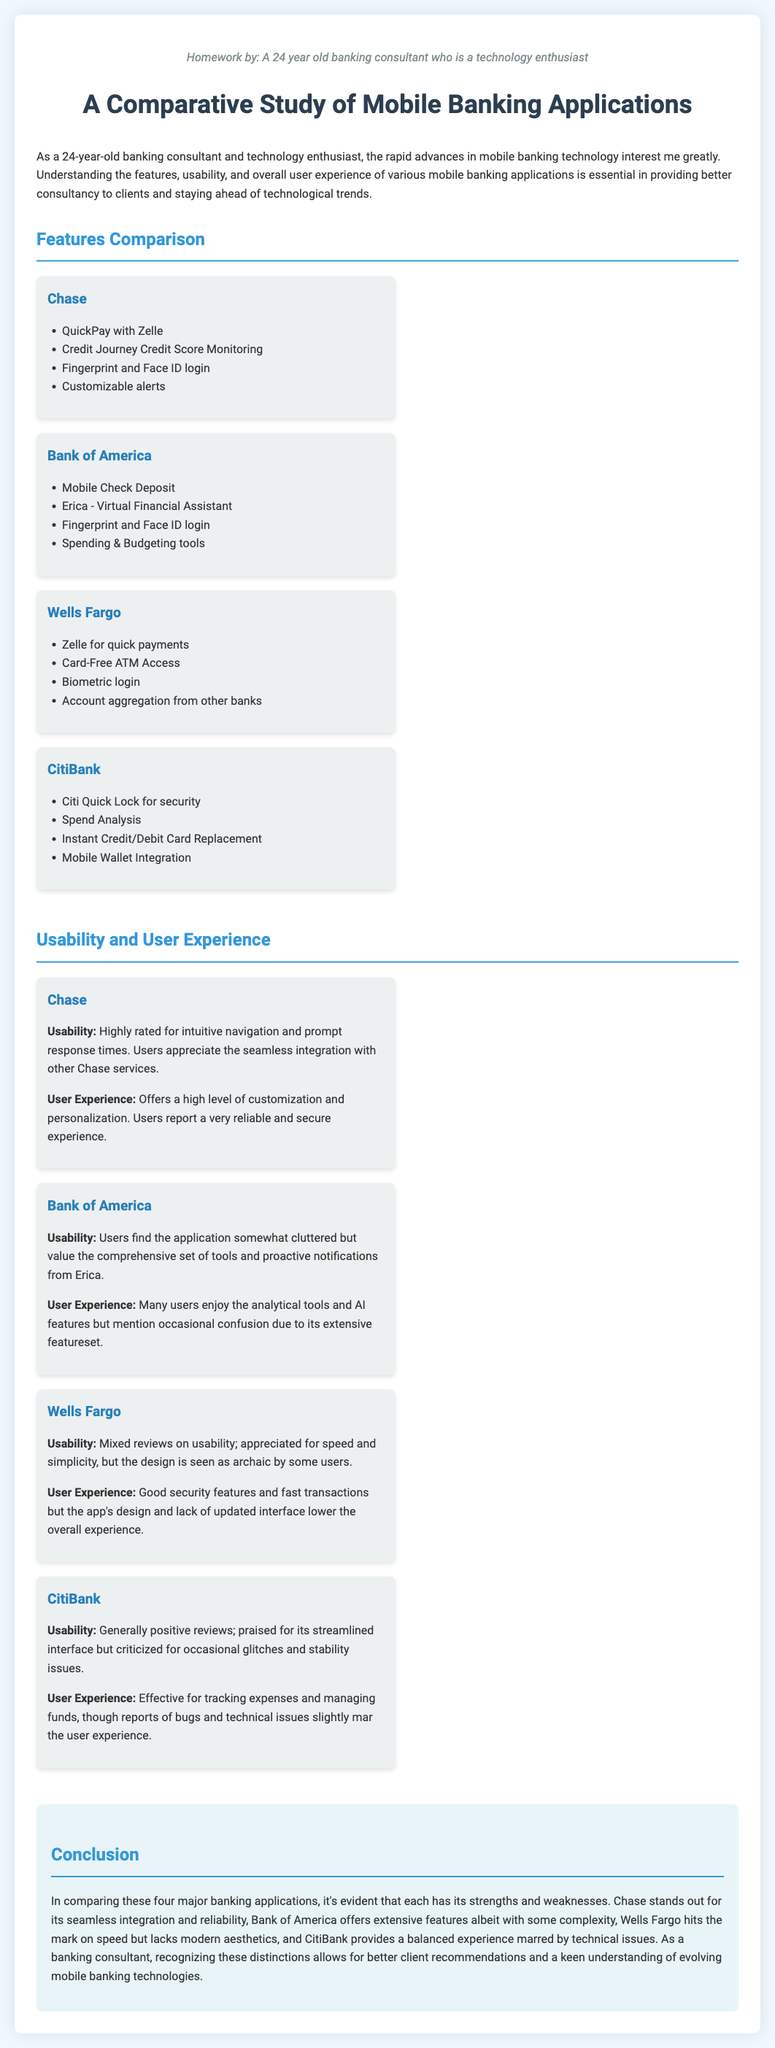What features does Chase offer? The features offered by Chase include QuickPay with Zelle, Credit Journey Credit Score Monitoring, Fingerprint and Face ID login, and Customizable alerts.
Answer: QuickPay with Zelle, Credit Journey Credit Score Monitoring, Fingerprint and Face ID login, Customizable alerts Which bank provides a Virtual Financial Assistant? The bank that offers a Virtual Financial Assistant is Bank of America.
Answer: Bank of America What is the user experience rating for Wells Fargo? Users report good security features and fast transactions but mention that the app's design and interface lower the overall experience.
Answer: Mixed Which bank has a feature called Citi Quick Lock? The bank with the feature Citi Quick Lock is CitiBank.
Answer: CitiBank How many banks are compared in this study? The total number of banks compared in this study is four.
Answer: Four What does CitiBank's user experience report mention about technical issues? The report states that CitiBank's user experience is marred by bugs and technical issues.
Answer: Bugs and technical issues What is a notable feature of Bank of America's app? A notable feature of Bank of America's app is Mobile Check Deposit.
Answer: Mobile Check Deposit Which bank is praised for seamless integration? Chase is praised for its seamless integration.
Answer: Chase What is the conclusion about Wells Fargo's design? The conclusion states that Wells Fargo's design is seen as archaic by some users.
Answer: Archaic 